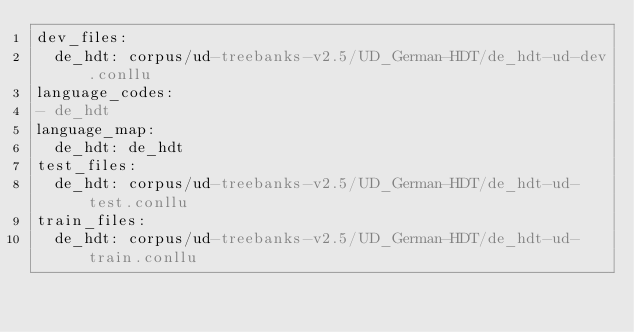<code> <loc_0><loc_0><loc_500><loc_500><_YAML_>dev_files:
  de_hdt: corpus/ud-treebanks-v2.5/UD_German-HDT/de_hdt-ud-dev.conllu
language_codes:
- de_hdt
language_map:
  de_hdt: de_hdt
test_files:
  de_hdt: corpus/ud-treebanks-v2.5/UD_German-HDT/de_hdt-ud-test.conllu
train_files:
  de_hdt: corpus/ud-treebanks-v2.5/UD_German-HDT/de_hdt-ud-train.conllu
</code> 